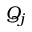<formula> <loc_0><loc_0><loc_500><loc_500>Q _ { j }</formula> 